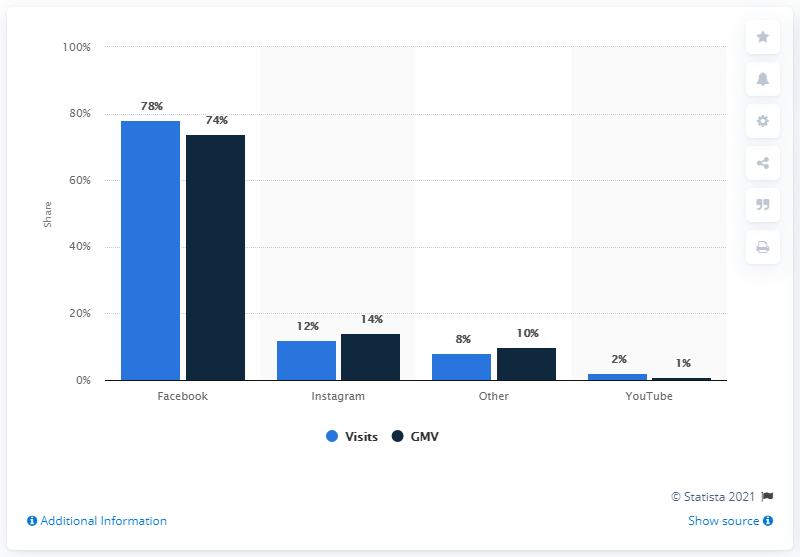List a handful of essential elements in this visual. In the first half of 2018, Facebook accounted for approximately 78% of online shopper traffic. Of the e-retail GMV in the first half of 2018, 74% came from Facebook. The statistical presentation provides a distribution of global online retail website social traffic and gross merchandise volume (GMV). 